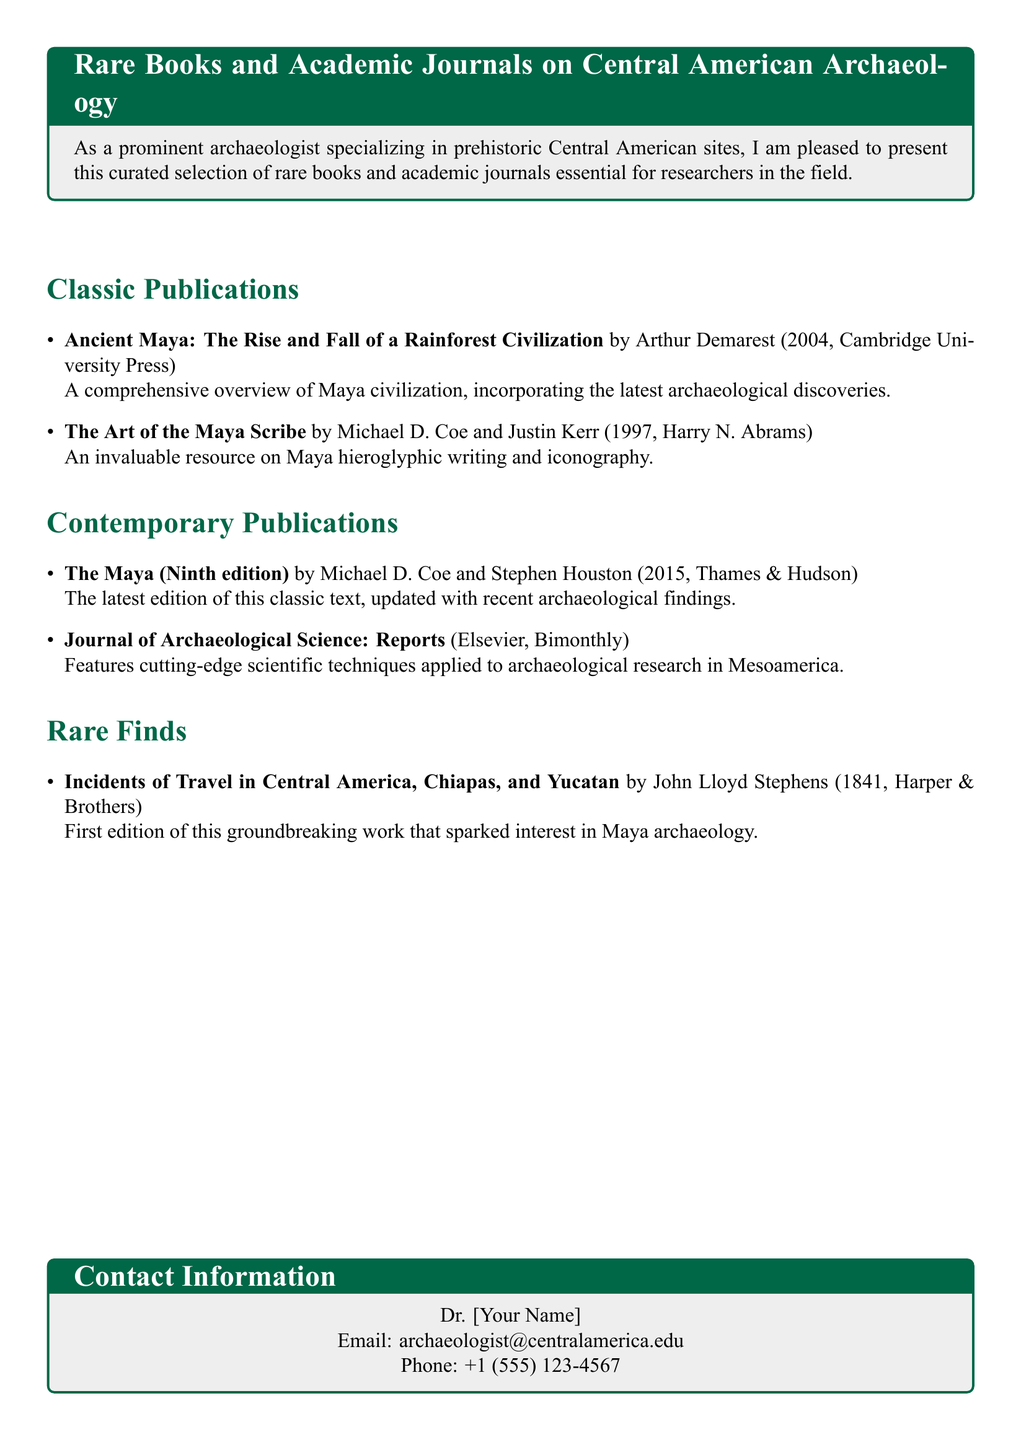what is the title of the classic publication by Arthur Demarest? The title of the classic publication is included in the document, highlighting its relevance to Maya civilization.
Answer: Ancient Maya: The Rise and Fall of a Rainforest Civilization who are the authors of "The Art of the Maya Scribe"? The document lists the authors of this classic publication, providing their names, which are relevant to the field of Maya iconography.
Answer: Michael D. Coe and Justin Kerr what year was "Incidents of Travel in Central America" published? The publication year is stated in the document, identifying when this significant work was released.
Answer: 1841 how often is the "Journal of Archaeological Science: Reports" published? The document specifies the publication frequency of this journal, indicating its relevance for contemporary archaeological research.
Answer: Bimonthly which contemporary publication has updated findings from recent archaeology? The document indicates which contemporary publication offers the latest information based on recent archaeological studies.
Answer: The Maya (Ninth edition) how many classic publications are listed in the document? The number of classic publications is specified in the document, providing a clear count of significant works included.
Answer: 2 what type of resource is "The Maya" classified as? The document categorizes this title as a contemporary publication, revealing its modern relevance in archaeological studies.
Answer: Contemporary who published "The Art of the Maya Scribe"? The publisher's name is included in the document, which connects to the publication's credibility and significance.
Answer: Harry N. Abrams 